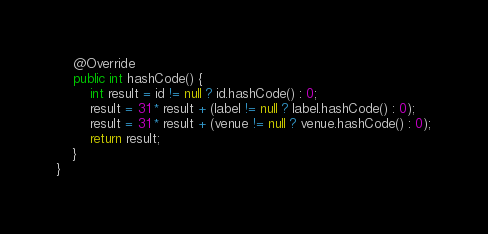Convert code to text. <code><loc_0><loc_0><loc_500><loc_500><_Java_>    @Override
    public int hashCode() {
        int result = id != null ? id.hashCode() : 0;
        result = 31 * result + (label != null ? label.hashCode() : 0);
        result = 31 * result + (venue != null ? venue.hashCode() : 0);
        return result;
    }
}
</code> 